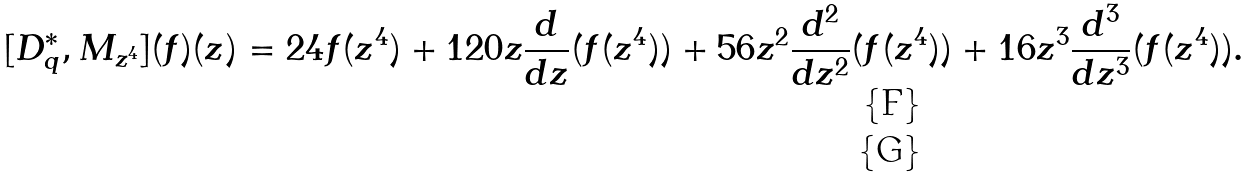Convert formula to latex. <formula><loc_0><loc_0><loc_500><loc_500>[ D ^ { * } _ { q } , M _ { z ^ { 4 } } ] ( f ) ( z ) = 2 4 f ( z ^ { 4 } ) + 1 2 0 z \frac { d } { d z } ( f ( z ^ { 4 } ) ) + 5 6 z ^ { 2 } \frac { d ^ { 2 } } { d z ^ { 2 } } ( f ( z ^ { 4 } ) ) + 1 6 z ^ { 3 } \frac { d ^ { 3 } } { d z ^ { 3 } } ( f ( z ^ { 4 } ) ) . \\</formula> 